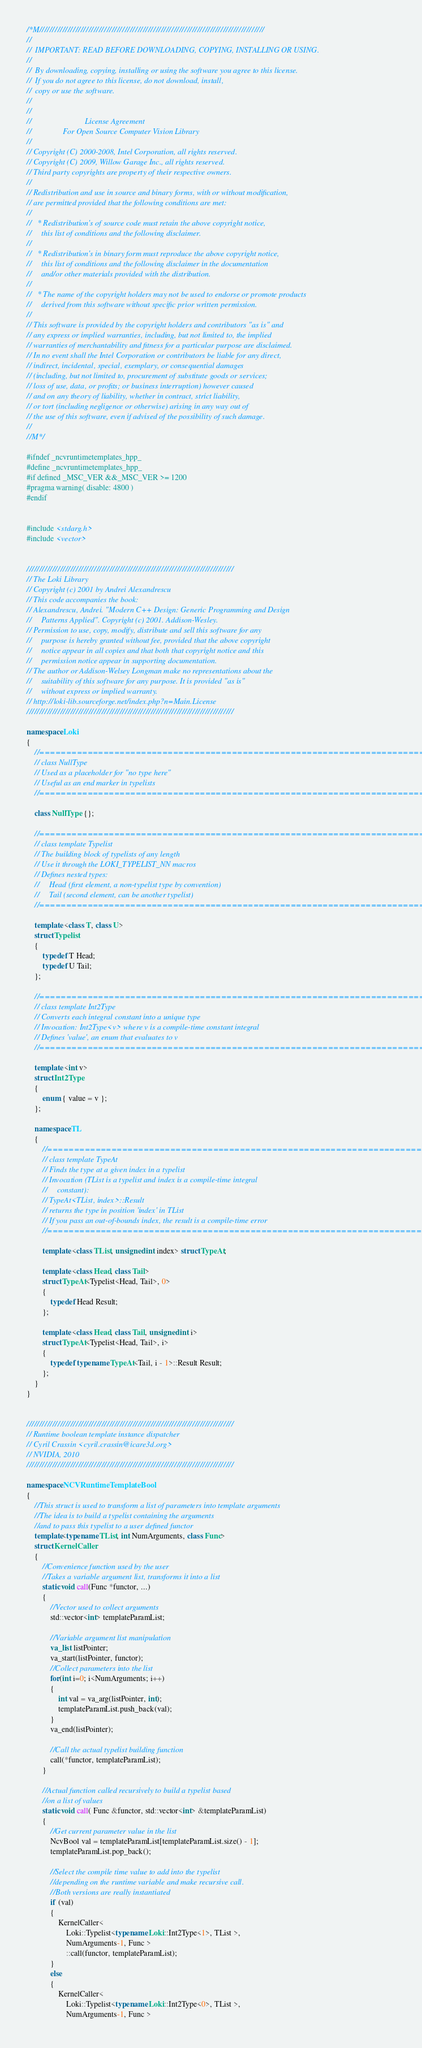Convert code to text. <code><loc_0><loc_0><loc_500><loc_500><_C++_>/*M///////////////////////////////////////////////////////////////////////////////////////
//
//  IMPORTANT: READ BEFORE DOWNLOADING, COPYING, INSTALLING OR USING.
//
//  By downloading, copying, installing or using the software you agree to this license.
//  If you do not agree to this license, do not download, install,
//  copy or use the software.
//
//
//                           License Agreement
//                For Open Source Computer Vision Library
//
// Copyright (C) 2000-2008, Intel Corporation, all rights reserved.
// Copyright (C) 2009, Willow Garage Inc., all rights reserved.
// Third party copyrights are property of their respective owners.
//
// Redistribution and use in source and binary forms, with or without modification,
// are permitted provided that the following conditions are met:
//
//   * Redistribution's of source code must retain the above copyright notice,
//     this list of conditions and the following disclaimer.
//
//   * Redistribution's in binary form must reproduce the above copyright notice,
//     this list of conditions and the following disclaimer in the documentation
//     and/or other materials provided with the distribution.
//
//   * The name of the copyright holders may not be used to endorse or promote products
//     derived from this software without specific prior written permission.
//
// This software is provided by the copyright holders and contributors "as is" and
// any express or implied warranties, including, but not limited to, the implied
// warranties of merchantability and fitness for a particular purpose are disclaimed.
// In no event shall the Intel Corporation or contributors be liable for any direct,
// indirect, incidental, special, exemplary, or consequential damages
// (including, but not limited to, procurement of substitute goods or services;
// loss of use, data, or profits; or business interruption) however caused
// and on any theory of liability, whether in contract, strict liability,
// or tort (including negligence or otherwise) arising in any way out of
// the use of this software, even if advised of the possibility of such damage.
//
//M*/

#ifndef _ncvruntimetemplates_hpp_
#define _ncvruntimetemplates_hpp_
#if defined _MSC_VER &&_MSC_VER >= 1200
#pragma warning( disable: 4800 )
#endif


#include <stdarg.h>
#include <vector>


////////////////////////////////////////////////////////////////////////////////
// The Loki Library
// Copyright (c) 2001 by Andrei Alexandrescu
// This code accompanies the book:
// Alexandrescu, Andrei. "Modern C++ Design: Generic Programming and Design
//     Patterns Applied". Copyright (c) 2001. Addison-Wesley.
// Permission to use, copy, modify, distribute and sell this software for any
//     purpose is hereby granted without fee, provided that the above copyright
//     notice appear in all copies and that both that copyright notice and this
//     permission notice appear in supporting documentation.
// The author or Addison-Welsey Longman make no representations about the
//     suitability of this software for any purpose. It is provided "as is"
//     without express or implied warranty.
// http://loki-lib.sourceforge.net/index.php?n=Main.License
////////////////////////////////////////////////////////////////////////////////

namespace Loki
{
    //==============================================================================
    // class NullType
    // Used as a placeholder for "no type here"
    // Useful as an end marker in typelists
    //==============================================================================

    class NullType {};

    //==============================================================================
    // class template Typelist
    // The building block of typelists of any length
    // Use it through the LOKI_TYPELIST_NN macros
    // Defines nested types:
    //     Head (first element, a non-typelist type by convention)
    //     Tail (second element, can be another typelist)
    //==============================================================================

    template <class T, class U>
    struct Typelist
    {
        typedef T Head;
        typedef U Tail;
    };

    //==============================================================================
    // class template Int2Type
    // Converts each integral constant into a unique type
    // Invocation: Int2Type<v> where v is a compile-time constant integral
    // Defines 'value', an enum that evaluates to v
    //==============================================================================

    template <int v>
    struct Int2Type
    {
        enum { value = v };
    };

    namespace TL
    {
        //==============================================================================
        // class template TypeAt
        // Finds the type at a given index in a typelist
        // Invocation (TList is a typelist and index is a compile-time integral
        //     constant):
        // TypeAt<TList, index>::Result
        // returns the type in position 'index' in TList
        // If you pass an out-of-bounds index, the result is a compile-time error
        //==============================================================================

        template <class TList, unsigned int index> struct TypeAt;

        template <class Head, class Tail>
        struct TypeAt<Typelist<Head, Tail>, 0>
        {
            typedef Head Result;
        };

        template <class Head, class Tail, unsigned int i>
        struct TypeAt<Typelist<Head, Tail>, i>
        {
            typedef typename TypeAt<Tail, i - 1>::Result Result;
        };
    }
}


////////////////////////////////////////////////////////////////////////////////
// Runtime boolean template instance dispatcher
// Cyril Crassin <cyril.crassin@icare3d.org>
// NVIDIA, 2010
////////////////////////////////////////////////////////////////////////////////

namespace NCVRuntimeTemplateBool
{
    //This struct is used to transform a list of parameters into template arguments
    //The idea is to build a typelist containing the arguments
    //and to pass this typelist to a user defined functor
    template<typename TList, int NumArguments, class Func>
    struct KernelCaller
    {
        //Convenience function used by the user
        //Takes a variable argument list, transforms it into a list
        static void call(Func *functor, ...)
        {
            //Vector used to collect arguments
            std::vector<int> templateParamList;

            //Variable argument list manipulation
            va_list listPointer;
            va_start(listPointer, functor);
            //Collect parameters into the list
            for(int i=0; i<NumArguments; i++)
            {
                int val = va_arg(listPointer, int);
                templateParamList.push_back(val);
            }
            va_end(listPointer);

            //Call the actual typelist building function
            call(*functor, templateParamList);
        }

        //Actual function called recursively to build a typelist based
        //on a list of values
        static void call( Func &functor, std::vector<int> &templateParamList)
        {
            //Get current parameter value in the list
            NcvBool val = templateParamList[templateParamList.size() - 1];
            templateParamList.pop_back();

            //Select the compile time value to add into the typelist
            //depending on the runtime variable and make recursive call.
            //Both versions are really instantiated
            if (val)
            {
                KernelCaller<
                    Loki::Typelist<typename Loki::Int2Type<1>, TList >,
                    NumArguments-1, Func >
                    ::call(functor, templateParamList);
            }
            else
            {
                KernelCaller<
                    Loki::Typelist<typename Loki::Int2Type<0>, TList >,
                    NumArguments-1, Func ></code> 